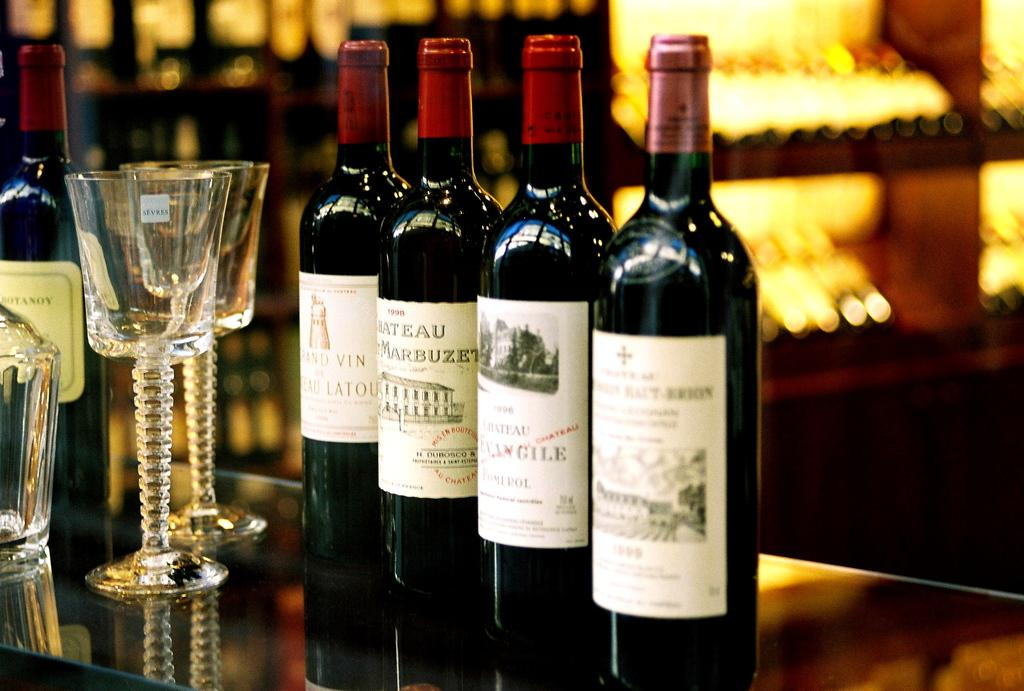<image>
Offer a succinct explanation of the picture presented. Very expensive red wine collection from 1998 on the bar counter. 